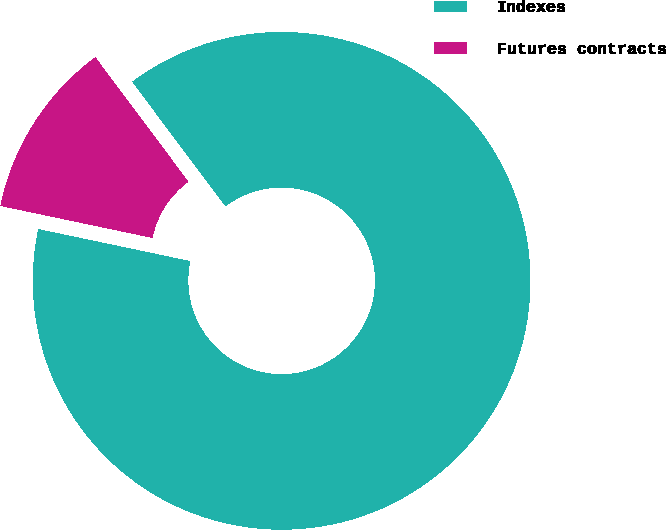<chart> <loc_0><loc_0><loc_500><loc_500><pie_chart><fcel>Indexes<fcel>Futures contracts<nl><fcel>88.52%<fcel>11.48%<nl></chart> 